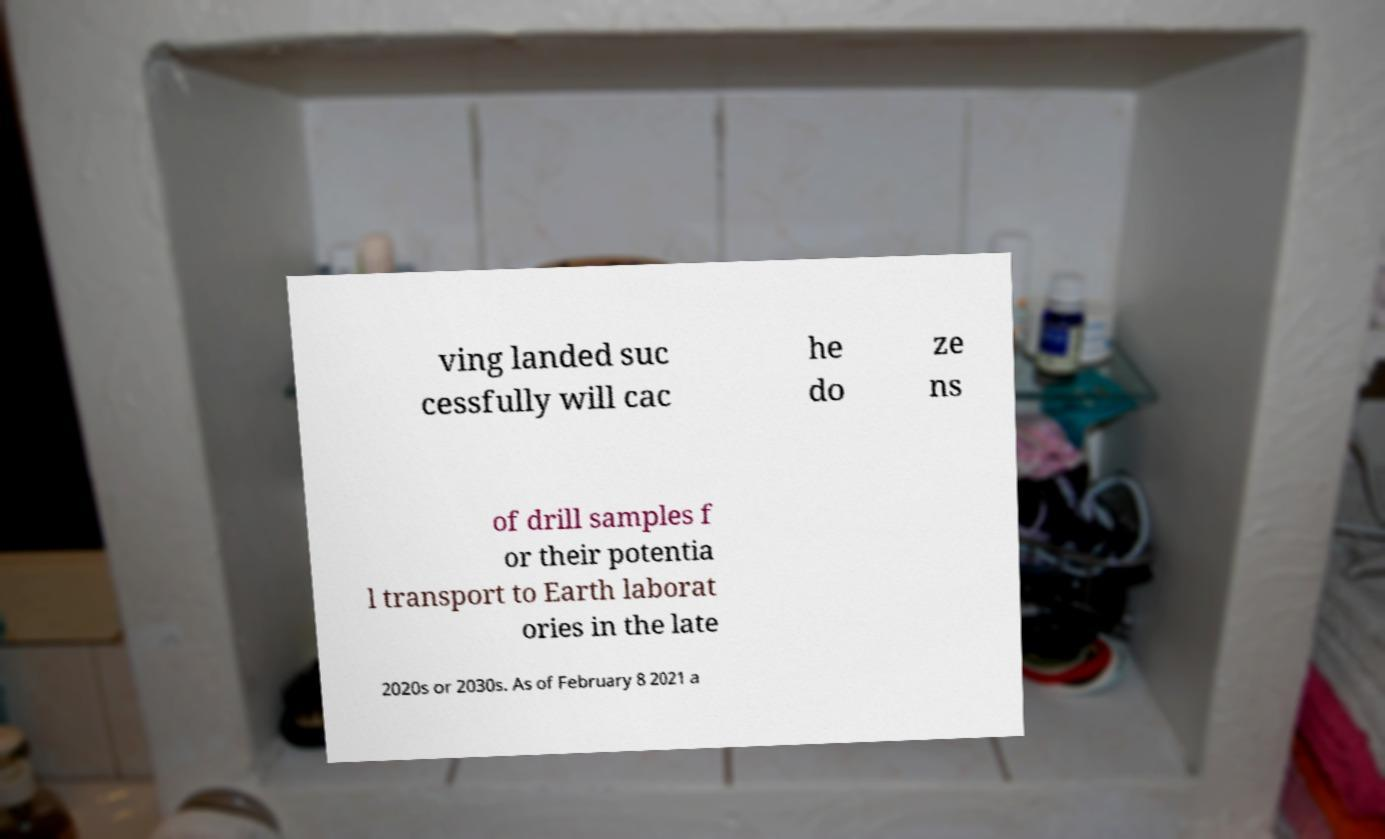For documentation purposes, I need the text within this image transcribed. Could you provide that? ving landed suc cessfully will cac he do ze ns of drill samples f or their potentia l transport to Earth laborat ories in the late 2020s or 2030s. As of February 8 2021 a 